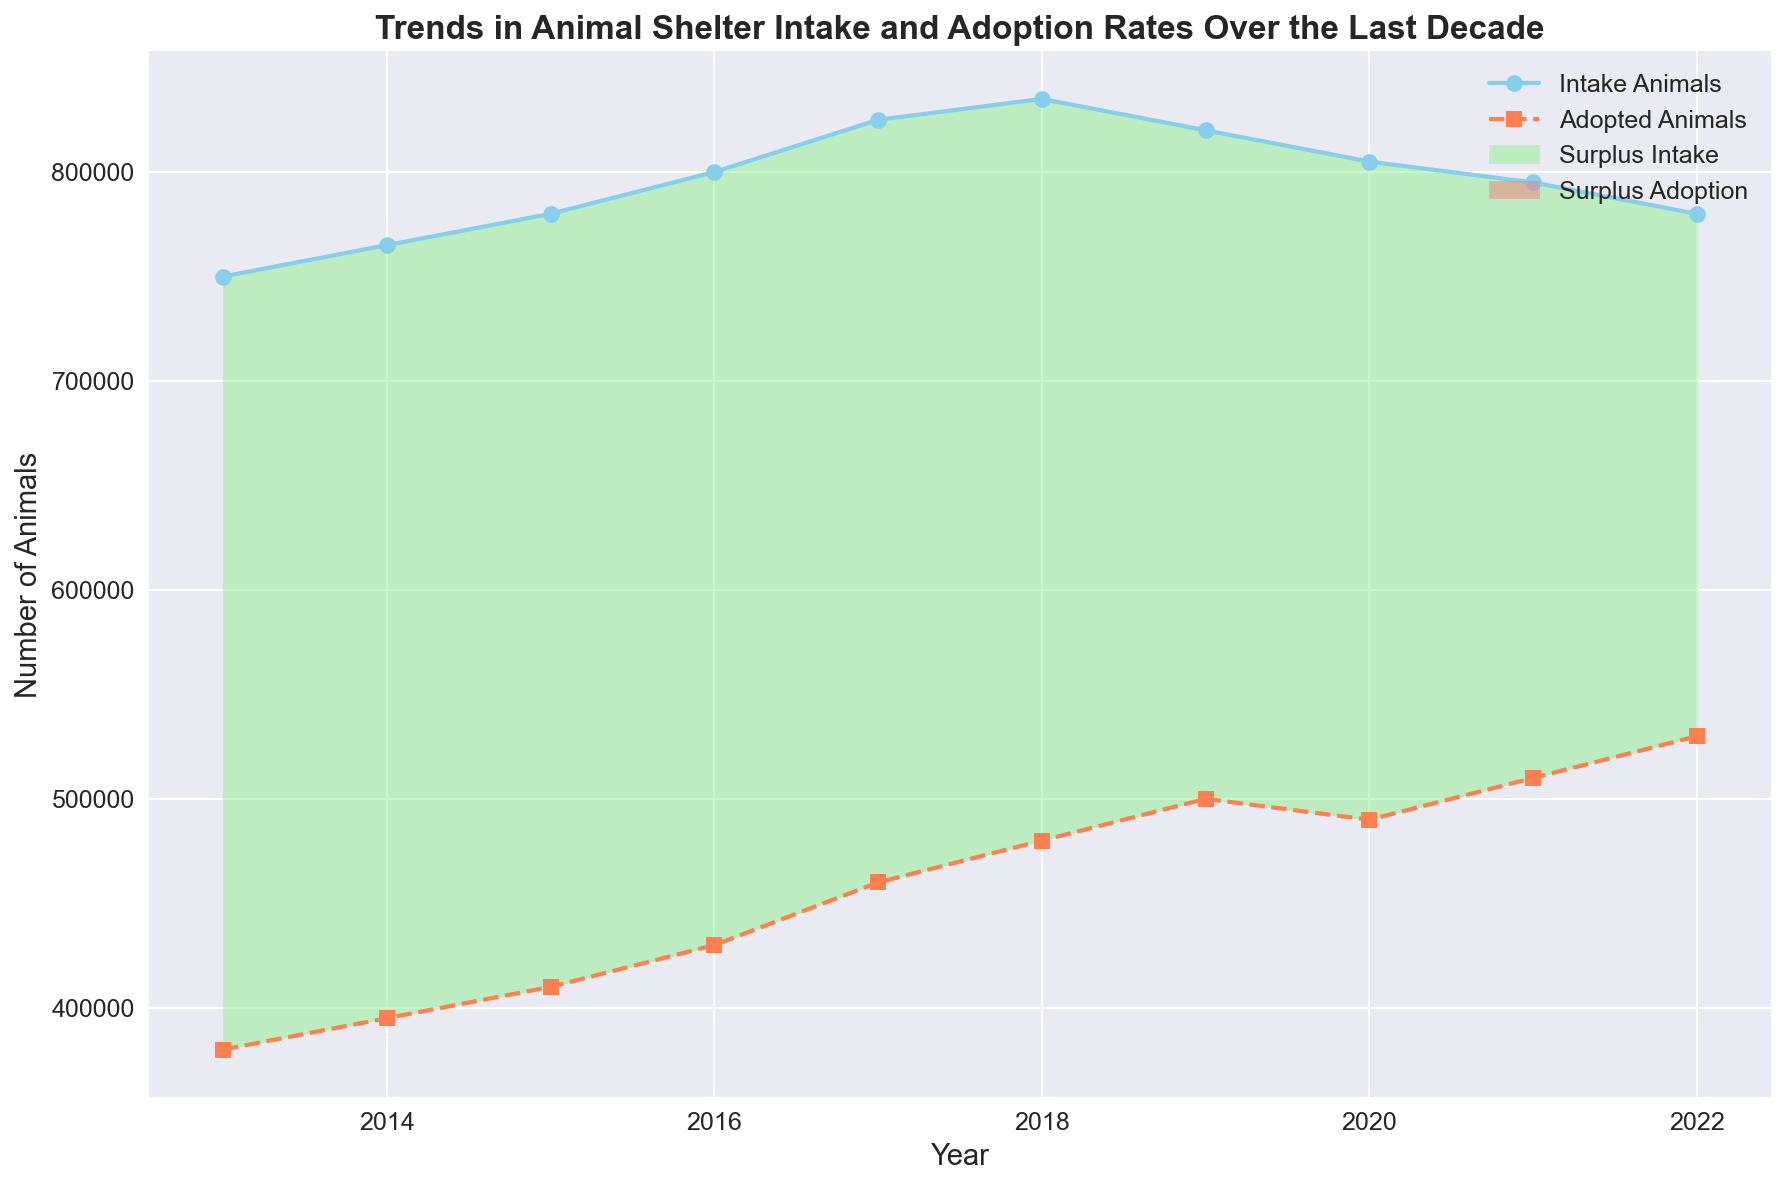What is the trend in the number of intake animals from 2013 to 2022? From the chart, it is evident that the number of intake animals increases from 2013 to 2018, reaching a peak, and then gradually decreases from 2019 to 2022.
Answer: Increasing until 2018, then decreasing How do the adoption rates change from 2013 to 2022? The adoption rates show a continuous increase over the period from 2013 to 2022.
Answer: Continuous increase In which year was the difference between intake and adoption rates the highest? From the chart, the largest vertical gap between the two lines occurs in 2013.
Answer: 2013 Which years had surplus intakes where the intake was greater than or equal to adoptions? The chart shows green-filled areas representing surplus intake. These areas exist from 2013 to 2018.
Answer: 2013 to 2018 In which year do the number of adopted animals surpass the intake of animals? The red-filled areas indicate surplus adoption. From the chart, it happens in 2021 and 2022.
Answer: 2021 and 2022 What is the total number of animals taken in by shelters over the last decade (2013-2022)? Adding up all the values from the "Intake_Animals" column: 750,000 + 765,000 + 780,000 + 800,000 + 825,000 + 835,000 + 820,000 + 805,000 + 795,000 + 780,000 = 7,955,000.
Answer: 7,955,000 By how much did the number of adopted animals increase from 2013 to 2022? Subtracting the number of adopted animals in 2013 from the number in 2022: 530,000 - 380,000 = 150,000.
Answer: 150,000 Which year saw the smallest difference between intake and adoption rates? The smallest difference corresponds to the smallest vertical gap between the lines, which happens in 2021.
Answer: 2021 Compare the trends in intake and adoption rates from 2019 to 2022. For intake rates, there's a steady decline from 2019 to 2022, while adoption rates increase notably within the same period.
Answer: Intake declines, adoption rises 